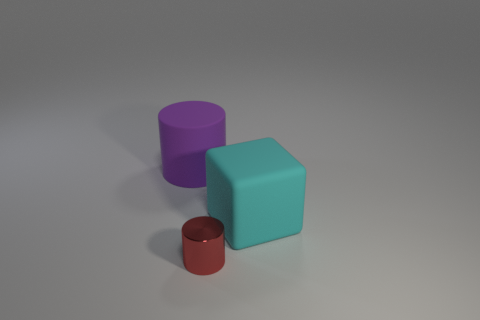What number of things are either small yellow objects or cylinders in front of the rubber block?
Provide a short and direct response. 1. What number of other objects are the same shape as the small thing?
Give a very brief answer. 1. Are the big block behind the small red cylinder and the large cylinder made of the same material?
Offer a terse response. Yes. How many things are either purple cylinders or big gray cylinders?
Give a very brief answer. 1. What is the size of the other object that is the same shape as the small metal thing?
Offer a very short reply. Large. The red metal thing is what size?
Your answer should be very brief. Small. Is the number of metal cylinders on the right side of the tiny metallic object greater than the number of red shiny cylinders?
Offer a very short reply. No. Is there anything else that is made of the same material as the big cyan block?
Your answer should be very brief. Yes. Does the cylinder that is to the left of the tiny cylinder have the same color as the large thing that is on the right side of the tiny red metal cylinder?
Keep it short and to the point. No. What is the material of the thing in front of the large rubber thing to the right of the thing that is behind the big cyan block?
Make the answer very short. Metal. 